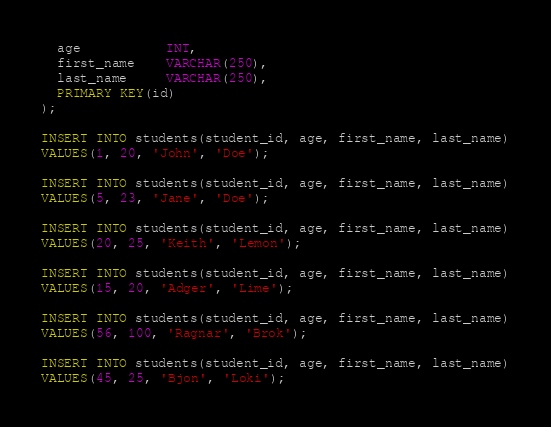Convert code to text. <code><loc_0><loc_0><loc_500><loc_500><_SQL_>  age           INT,
  first_name    VARCHAR(250),
  last_name     VARCHAR(250),
  PRIMARY KEY(id)
);

INSERT INTO students(student_id, age, first_name, last_name)
VALUES(1, 20, 'John', 'Doe');

INSERT INTO students(student_id, age, first_name, last_name)
VALUES(5, 23, 'Jane', 'Doe');

INSERT INTO students(student_id, age, first_name, last_name)
VALUES(20, 25, 'Keith', 'Lemon');

INSERT INTO students(student_id, age, first_name, last_name)
VALUES(15, 20, 'Adger', 'Lime');

INSERT INTO students(student_id, age, first_name, last_name)
VALUES(56, 100, 'Ragnar', 'Brok');

INSERT INTO students(student_id, age, first_name, last_name)
VALUES(45, 25, 'Bjon', 'Loki');</code> 